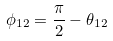<formula> <loc_0><loc_0><loc_500><loc_500>\phi _ { 1 2 } = \frac { \pi } { 2 } - \theta _ { 1 2 }</formula> 